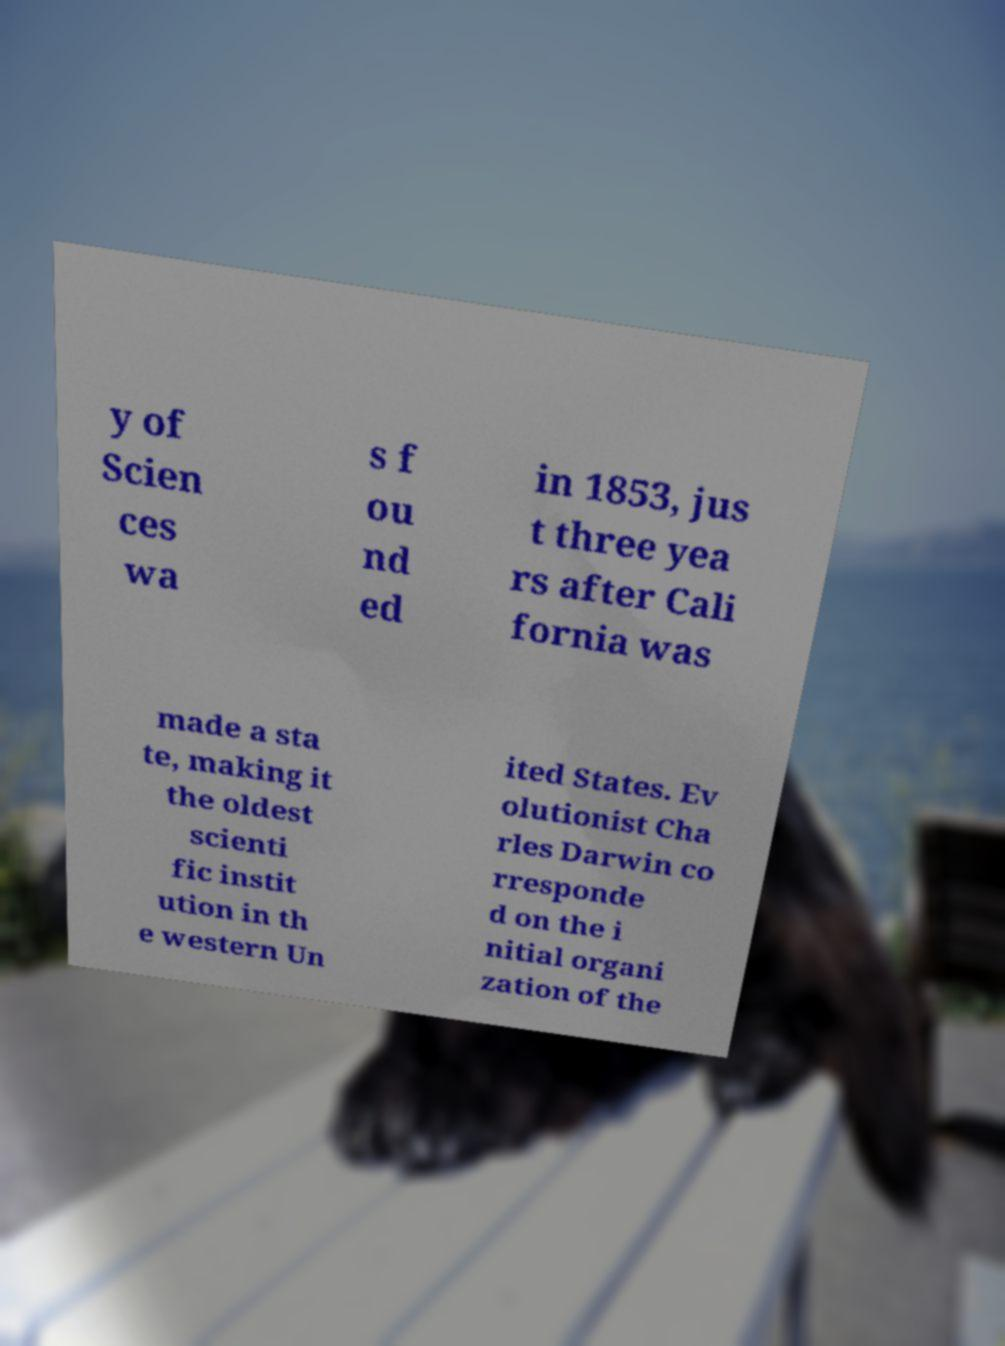I need the written content from this picture converted into text. Can you do that? y of Scien ces wa s f ou nd ed in 1853, jus t three yea rs after Cali fornia was made a sta te, making it the oldest scienti fic instit ution in th e western Un ited States. Ev olutionist Cha rles Darwin co rresponde d on the i nitial organi zation of the 